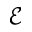Convert formula to latex. <formula><loc_0><loc_0><loc_500><loc_500>\mathcal { E }</formula> 